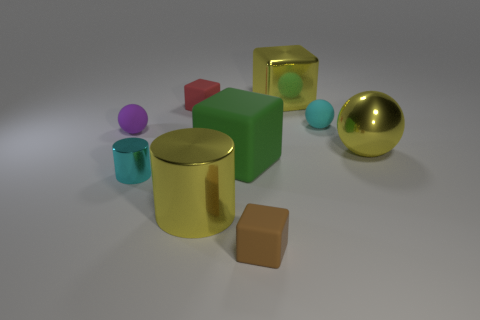How many things are either small brown blocks or large green cubes?
Your response must be concise. 2. Are there any big things right of the yellow metallic cylinder?
Your answer should be compact. Yes. Are there any tiny balls made of the same material as the large green block?
Make the answer very short. Yes. There is a matte thing that is the same color as the tiny shiny object; what size is it?
Offer a very short reply. Small. How many balls are either yellow objects or tiny red matte things?
Ensure brevity in your answer.  1. Is the number of cubes behind the big yellow ball greater than the number of tiny brown objects that are on the right side of the big green object?
Keep it short and to the point. Yes. How many small cylinders are the same color as the big cylinder?
Give a very brief answer. 0. What is the size of the purple ball that is the same material as the brown object?
Offer a terse response. Small. How many objects are either yellow metallic objects that are left of the large yellow ball or big blue metal objects?
Your answer should be compact. 2. Is the color of the ball that is on the left side of the cyan matte sphere the same as the large rubber object?
Provide a succinct answer. No. 